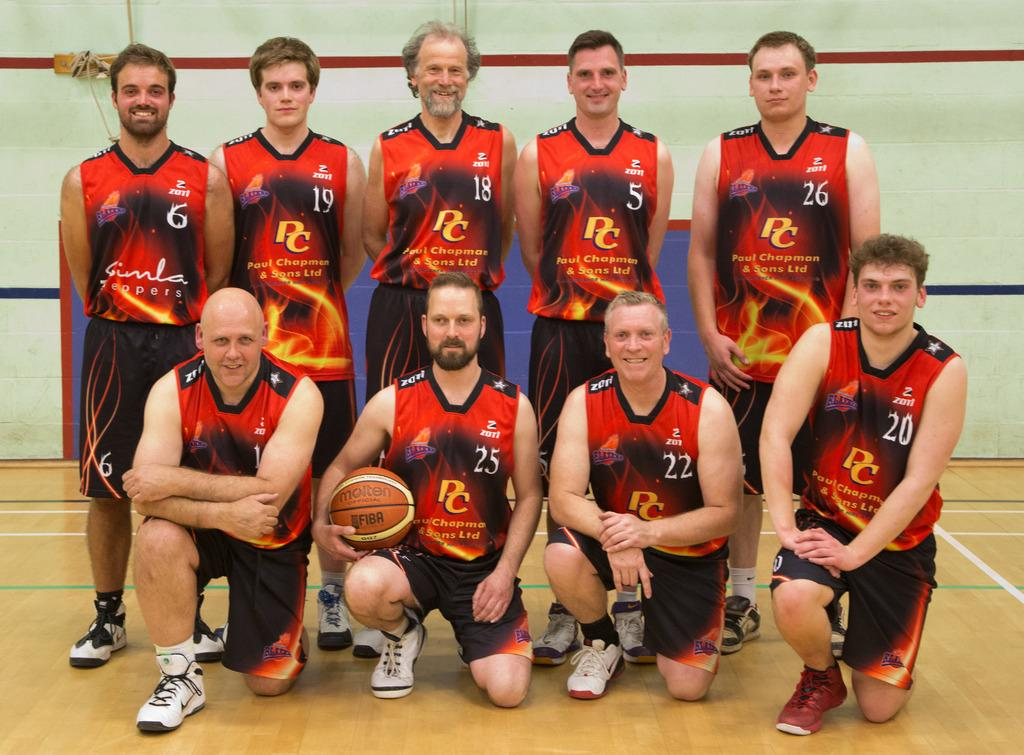What are the persons in the image doing? The persons in the image are posing for a camera. What is the facial expression of the persons? The persons are smiling. What object is one person holding? One person is holding a ball. What is the surface beneath the persons? There is a floor in the image. What can be seen behind the persons? There is a wall in the background of the image. What type of gate can be seen in the image? There is no gate present in the image. What role does the government play in the image? The government is not mentioned or depicted in the image. 